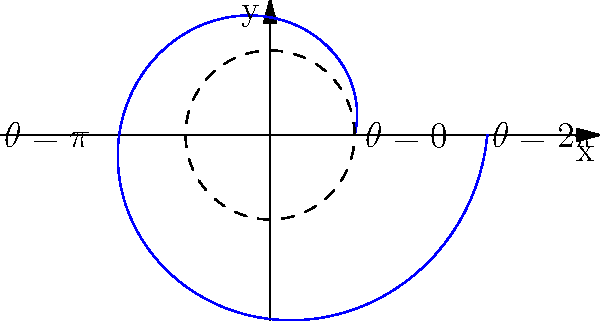In a simple business growth model represented using polar coordinates, the radius $r$ is given by the equation $r = 2 + 0.5\theta$, where $\theta$ is the angle in radians. If one complete revolution ($2\pi$ radians) represents one year of business growth, what does the spiral's distance from the origin at $\theta = 2\pi$ represent in terms of business performance? To understand this business growth model using polar coordinates, let's break it down step-by-step:

1. The equation $r = 2 + 0.5\theta$ represents a spiral, where:
   - $r$ is the radius (distance from the origin)
   - $\theta$ is the angle in radians
   - 2 is the starting radius (initial business size)
   - 0.5 is the growth rate

2. One complete revolution ($2\pi$ radians) represents one year of business growth.

3. To find the radius at $\theta = 2\pi$ (one year):
   $r = 2 + 0.5(2\pi)$
   $r = 2 + \pi$
   $r \approx 5.14$

4. The initial radius was 2, representing the initial business size.

5. After one year (at $\theta = 2\pi$), the radius has increased to approximately 5.14.

6. This increase in radius represents the growth of the business over one year.

7. To calculate the growth factor:
   Growth factor = Final size / Initial size
   $\approx 5.14 / 2 = 2.57$

Therefore, the spiral's distance from the origin at $\theta = 2\pi$ represents a 2.57-fold increase in business size or performance after one year of growth.
Answer: 2.57-fold increase in business size/performance 